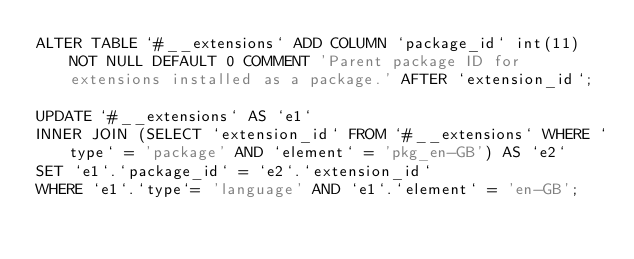<code> <loc_0><loc_0><loc_500><loc_500><_SQL_>ALTER TABLE `#__extensions` ADD COLUMN `package_id` int(11) NOT NULL DEFAULT 0 COMMENT 'Parent package ID for extensions installed as a package.' AFTER `extension_id`;

UPDATE `#__extensions` AS `e1`
INNER JOIN (SELECT `extension_id` FROM `#__extensions` WHERE `type` = 'package' AND `element` = 'pkg_en-GB') AS `e2`
SET `e1`.`package_id` = `e2`.`extension_id`
WHERE `e1`.`type`= 'language' AND `e1`.`element` = 'en-GB';
</code> 